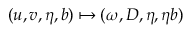Convert formula to latex. <formula><loc_0><loc_0><loc_500><loc_500>( u , v , \eta , b ) \mapsto ( \omega , D , \eta , \eta b )</formula> 